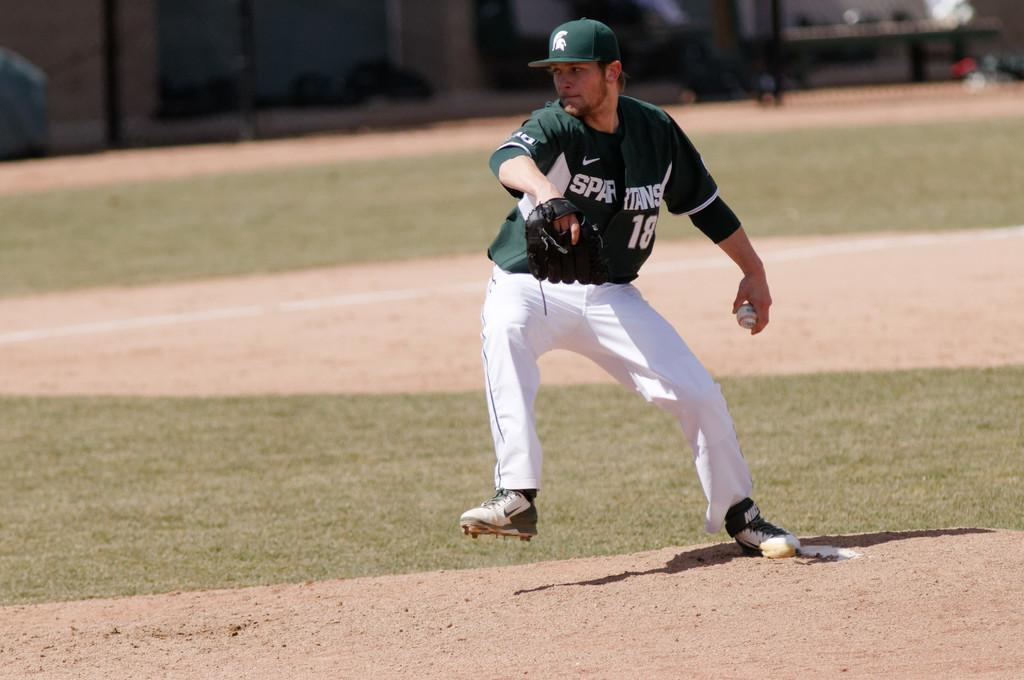<image>
Summarize the visual content of the image. A baseball player wearing a green jersey with Spartans and 18 on it is about to throw the ball 